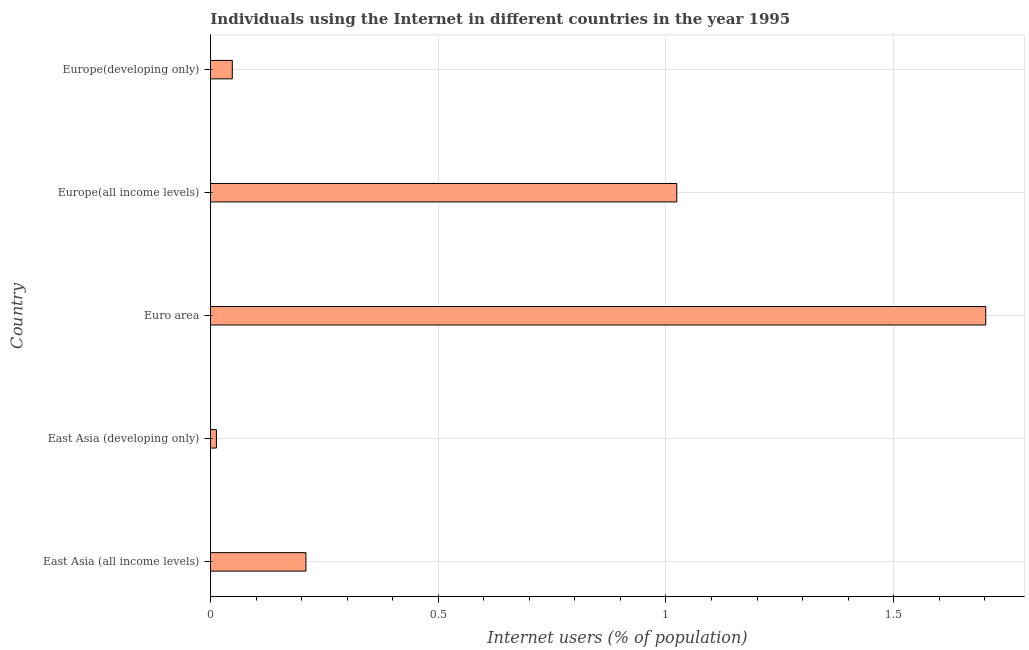Does the graph contain any zero values?
Provide a succinct answer. No. Does the graph contain grids?
Provide a short and direct response. Yes. What is the title of the graph?
Offer a terse response. Individuals using the Internet in different countries in the year 1995. What is the label or title of the X-axis?
Your answer should be very brief. Internet users (% of population). What is the label or title of the Y-axis?
Offer a terse response. Country. What is the number of internet users in East Asia (developing only)?
Ensure brevity in your answer.  0.01. Across all countries, what is the maximum number of internet users?
Give a very brief answer. 1.7. Across all countries, what is the minimum number of internet users?
Provide a short and direct response. 0.01. In which country was the number of internet users minimum?
Provide a short and direct response. East Asia (developing only). What is the sum of the number of internet users?
Your answer should be compact. 3. What is the difference between the number of internet users in Euro area and Europe(developing only)?
Your answer should be very brief. 1.65. What is the average number of internet users per country?
Your answer should be very brief. 0.6. What is the median number of internet users?
Offer a very short reply. 0.21. In how many countries, is the number of internet users greater than 1.6 %?
Your answer should be compact. 1. What is the ratio of the number of internet users in Europe(all income levels) to that in Europe(developing only)?
Make the answer very short. 21.36. Is the number of internet users in East Asia (developing only) less than that in Europe(all income levels)?
Ensure brevity in your answer.  Yes. Is the difference between the number of internet users in Euro area and Europe(all income levels) greater than the difference between any two countries?
Keep it short and to the point. No. What is the difference between the highest and the second highest number of internet users?
Provide a succinct answer. 0.68. Is the sum of the number of internet users in East Asia (all income levels) and Euro area greater than the maximum number of internet users across all countries?
Ensure brevity in your answer.  Yes. What is the difference between the highest and the lowest number of internet users?
Offer a very short reply. 1.69. In how many countries, is the number of internet users greater than the average number of internet users taken over all countries?
Your answer should be very brief. 2. Are all the bars in the graph horizontal?
Your answer should be compact. Yes. Are the values on the major ticks of X-axis written in scientific E-notation?
Keep it short and to the point. No. What is the Internet users (% of population) in East Asia (all income levels)?
Keep it short and to the point. 0.21. What is the Internet users (% of population) of East Asia (developing only)?
Keep it short and to the point. 0.01. What is the Internet users (% of population) of Euro area?
Provide a short and direct response. 1.7. What is the Internet users (% of population) in Europe(all income levels)?
Provide a succinct answer. 1.02. What is the Internet users (% of population) of Europe(developing only)?
Ensure brevity in your answer.  0.05. What is the difference between the Internet users (% of population) in East Asia (all income levels) and East Asia (developing only)?
Offer a very short reply. 0.2. What is the difference between the Internet users (% of population) in East Asia (all income levels) and Euro area?
Provide a short and direct response. -1.49. What is the difference between the Internet users (% of population) in East Asia (all income levels) and Europe(all income levels)?
Keep it short and to the point. -0.81. What is the difference between the Internet users (% of population) in East Asia (all income levels) and Europe(developing only)?
Your answer should be very brief. 0.16. What is the difference between the Internet users (% of population) in East Asia (developing only) and Euro area?
Keep it short and to the point. -1.69. What is the difference between the Internet users (% of population) in East Asia (developing only) and Europe(all income levels)?
Offer a terse response. -1.01. What is the difference between the Internet users (% of population) in East Asia (developing only) and Europe(developing only)?
Your answer should be very brief. -0.03. What is the difference between the Internet users (% of population) in Euro area and Europe(all income levels)?
Your answer should be very brief. 0.68. What is the difference between the Internet users (% of population) in Euro area and Europe(developing only)?
Ensure brevity in your answer.  1.65. What is the difference between the Internet users (% of population) in Europe(all income levels) and Europe(developing only)?
Your answer should be very brief. 0.98. What is the ratio of the Internet users (% of population) in East Asia (all income levels) to that in East Asia (developing only)?
Offer a very short reply. 16.07. What is the ratio of the Internet users (% of population) in East Asia (all income levels) to that in Euro area?
Offer a terse response. 0.12. What is the ratio of the Internet users (% of population) in East Asia (all income levels) to that in Europe(all income levels)?
Offer a terse response. 0.2. What is the ratio of the Internet users (% of population) in East Asia (all income levels) to that in Europe(developing only)?
Keep it short and to the point. 4.37. What is the ratio of the Internet users (% of population) in East Asia (developing only) to that in Euro area?
Offer a very short reply. 0.01. What is the ratio of the Internet users (% of population) in East Asia (developing only) to that in Europe(all income levels)?
Ensure brevity in your answer.  0.01. What is the ratio of the Internet users (% of population) in East Asia (developing only) to that in Europe(developing only)?
Keep it short and to the point. 0.27. What is the ratio of the Internet users (% of population) in Euro area to that in Europe(all income levels)?
Give a very brief answer. 1.66. What is the ratio of the Internet users (% of population) in Euro area to that in Europe(developing only)?
Ensure brevity in your answer.  35.51. What is the ratio of the Internet users (% of population) in Europe(all income levels) to that in Europe(developing only)?
Offer a terse response. 21.36. 